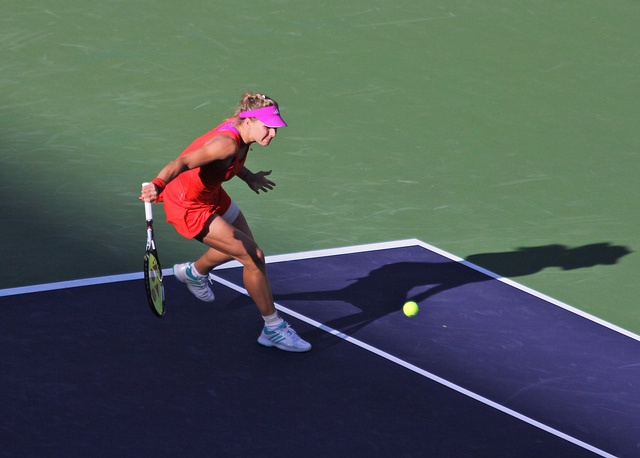Describe the objects in this image and their specific colors. I can see people in green, black, salmon, maroon, and brown tones, tennis racket in green, black, gray, lavender, and darkgreen tones, and sports ball in green, khaki, and lightgreen tones in this image. 